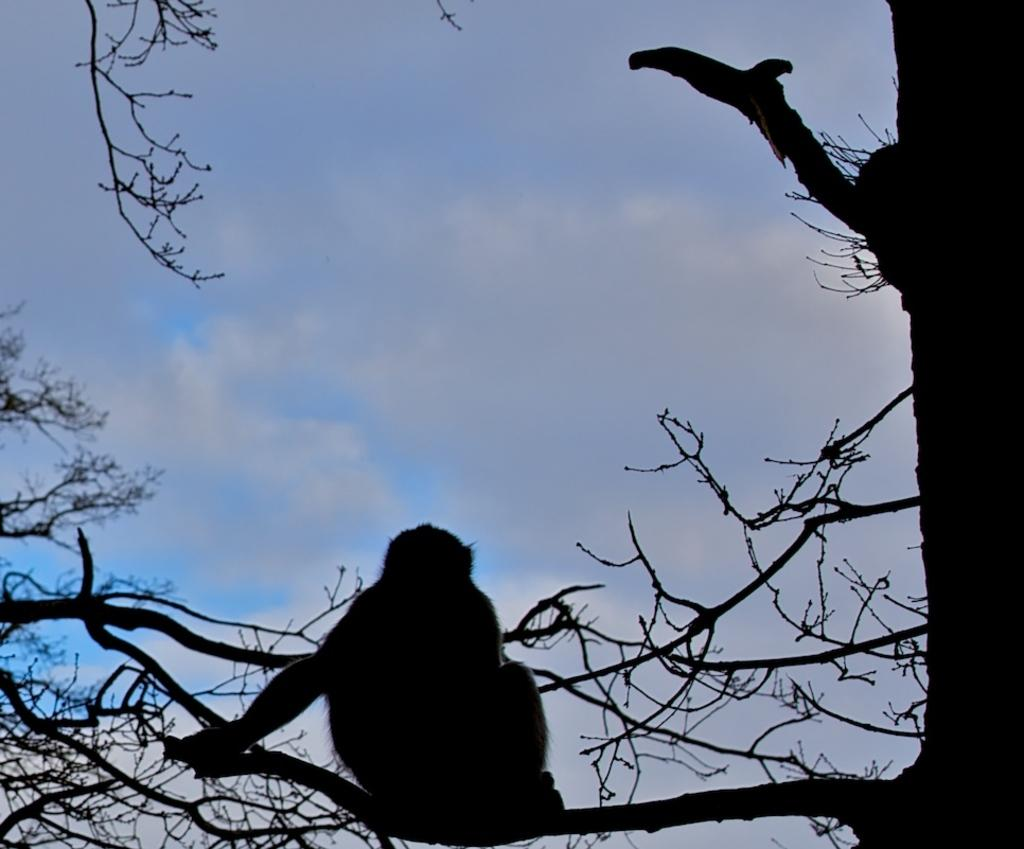What type of animal can be seen in the image? There is an animal in the image, but its specific type cannot be determined from the provided facts. Where is the animal located in the image? The animal is sitting on branches in the image. What can be seen in the background of the image? The sky is visible in the image. What shape is the snail's head in the image? There are no snails or heads present in the image, so this question cannot be answered. 